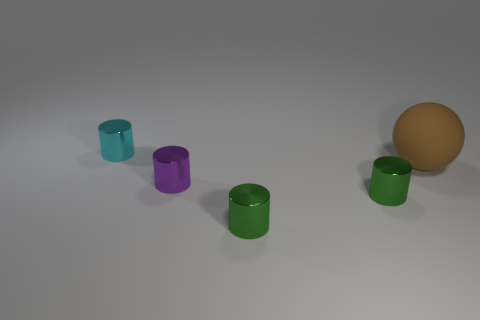What number of other spheres are made of the same material as the big ball?
Provide a short and direct response. 0. Is the number of large matte spheres that are behind the cyan cylinder less than the number of small gray cylinders?
Your answer should be compact. No. How many spheres are there?
Provide a succinct answer. 1. What number of metal cylinders have the same color as the matte thing?
Offer a very short reply. 0. Is the brown thing the same shape as the tiny purple thing?
Your answer should be very brief. No. What size is the metal thing that is to the left of the purple thing that is in front of the brown object?
Make the answer very short. Small. Are there any cyan things of the same size as the purple thing?
Make the answer very short. Yes. Do the cylinder that is behind the brown rubber object and the ball that is on the right side of the purple cylinder have the same size?
Ensure brevity in your answer.  No. There is a big object that is to the right of the purple metallic cylinder that is in front of the sphere; what is its shape?
Give a very brief answer. Sphere. What number of tiny metallic objects are to the left of the purple metallic object?
Give a very brief answer. 1. 